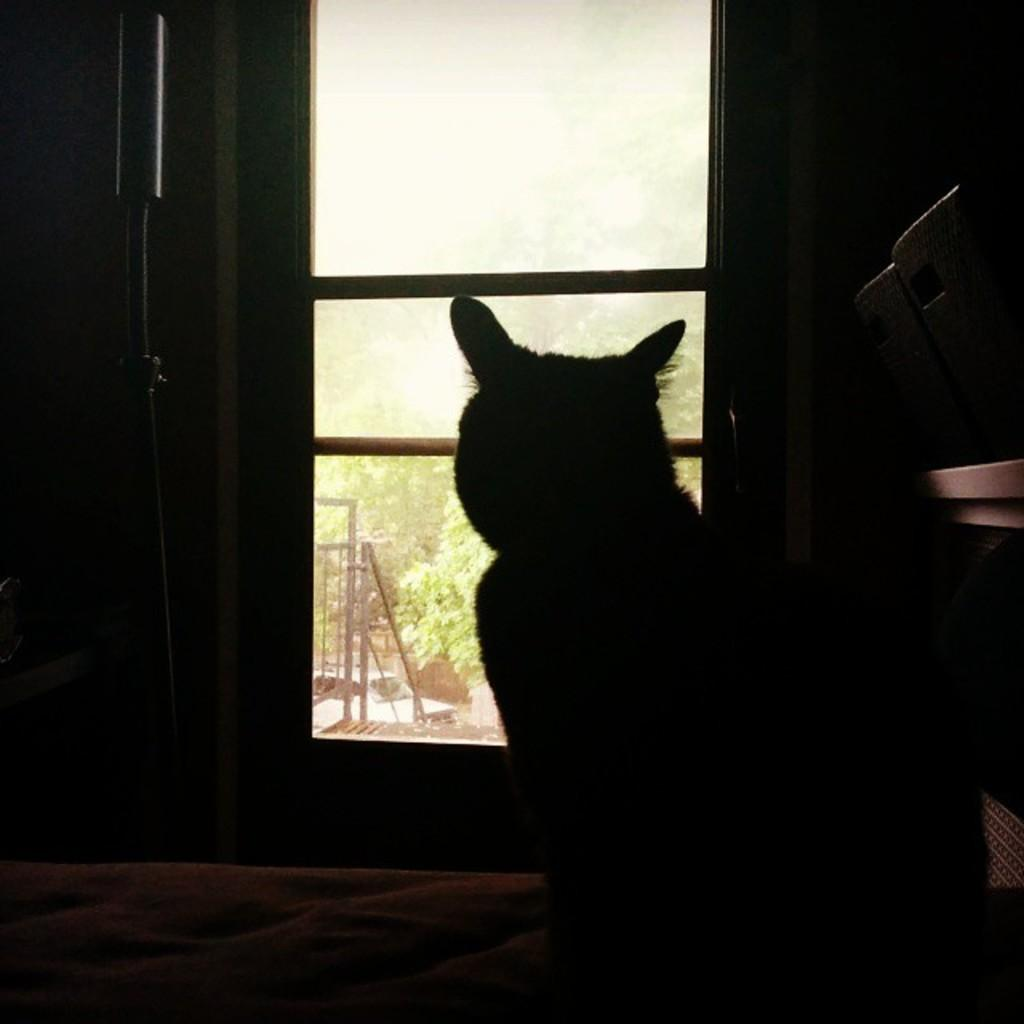What type of furniture is present in the image? There is a bed in the image. What type of animal can be seen in the image? There is a cat in the image. What is visible through the window in the image? Trees, the sky, and a railing are visible through the window in the image. Can you describe the view outside the window? The view outside the window includes trees, the sky, and a railing. What other unspecified objects can be seen in the image? There are other unspecified objects in the image, but their details are not provided. What type of ornament is hanging from the sheet in the image? There is no sheet or ornament mentioned in the image; it only includes a bed, a cat, a window, trees, the sky, and a railing. 